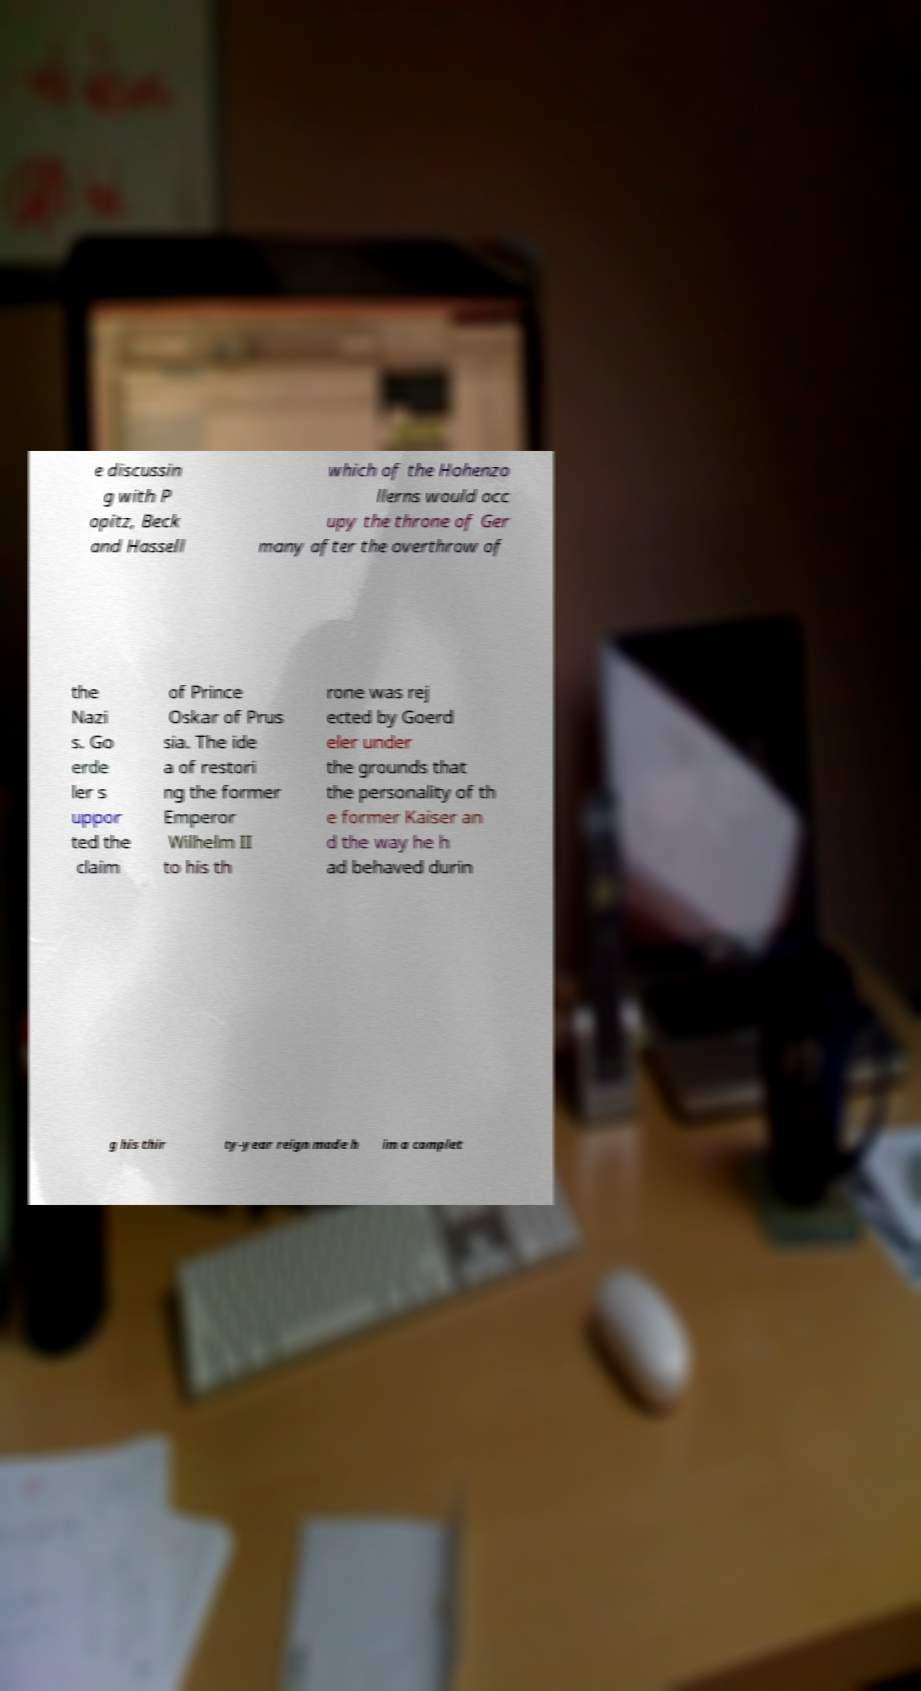I need the written content from this picture converted into text. Can you do that? e discussin g with P opitz, Beck and Hassell which of the Hohenzo llerns would occ upy the throne of Ger many after the overthrow of the Nazi s. Go erde ler s uppor ted the claim of Prince Oskar of Prus sia. The ide a of restori ng the former Emperor Wilhelm II to his th rone was rej ected by Goerd eler under the grounds that the personality of th e former Kaiser an d the way he h ad behaved durin g his thir ty-year reign made h im a complet 